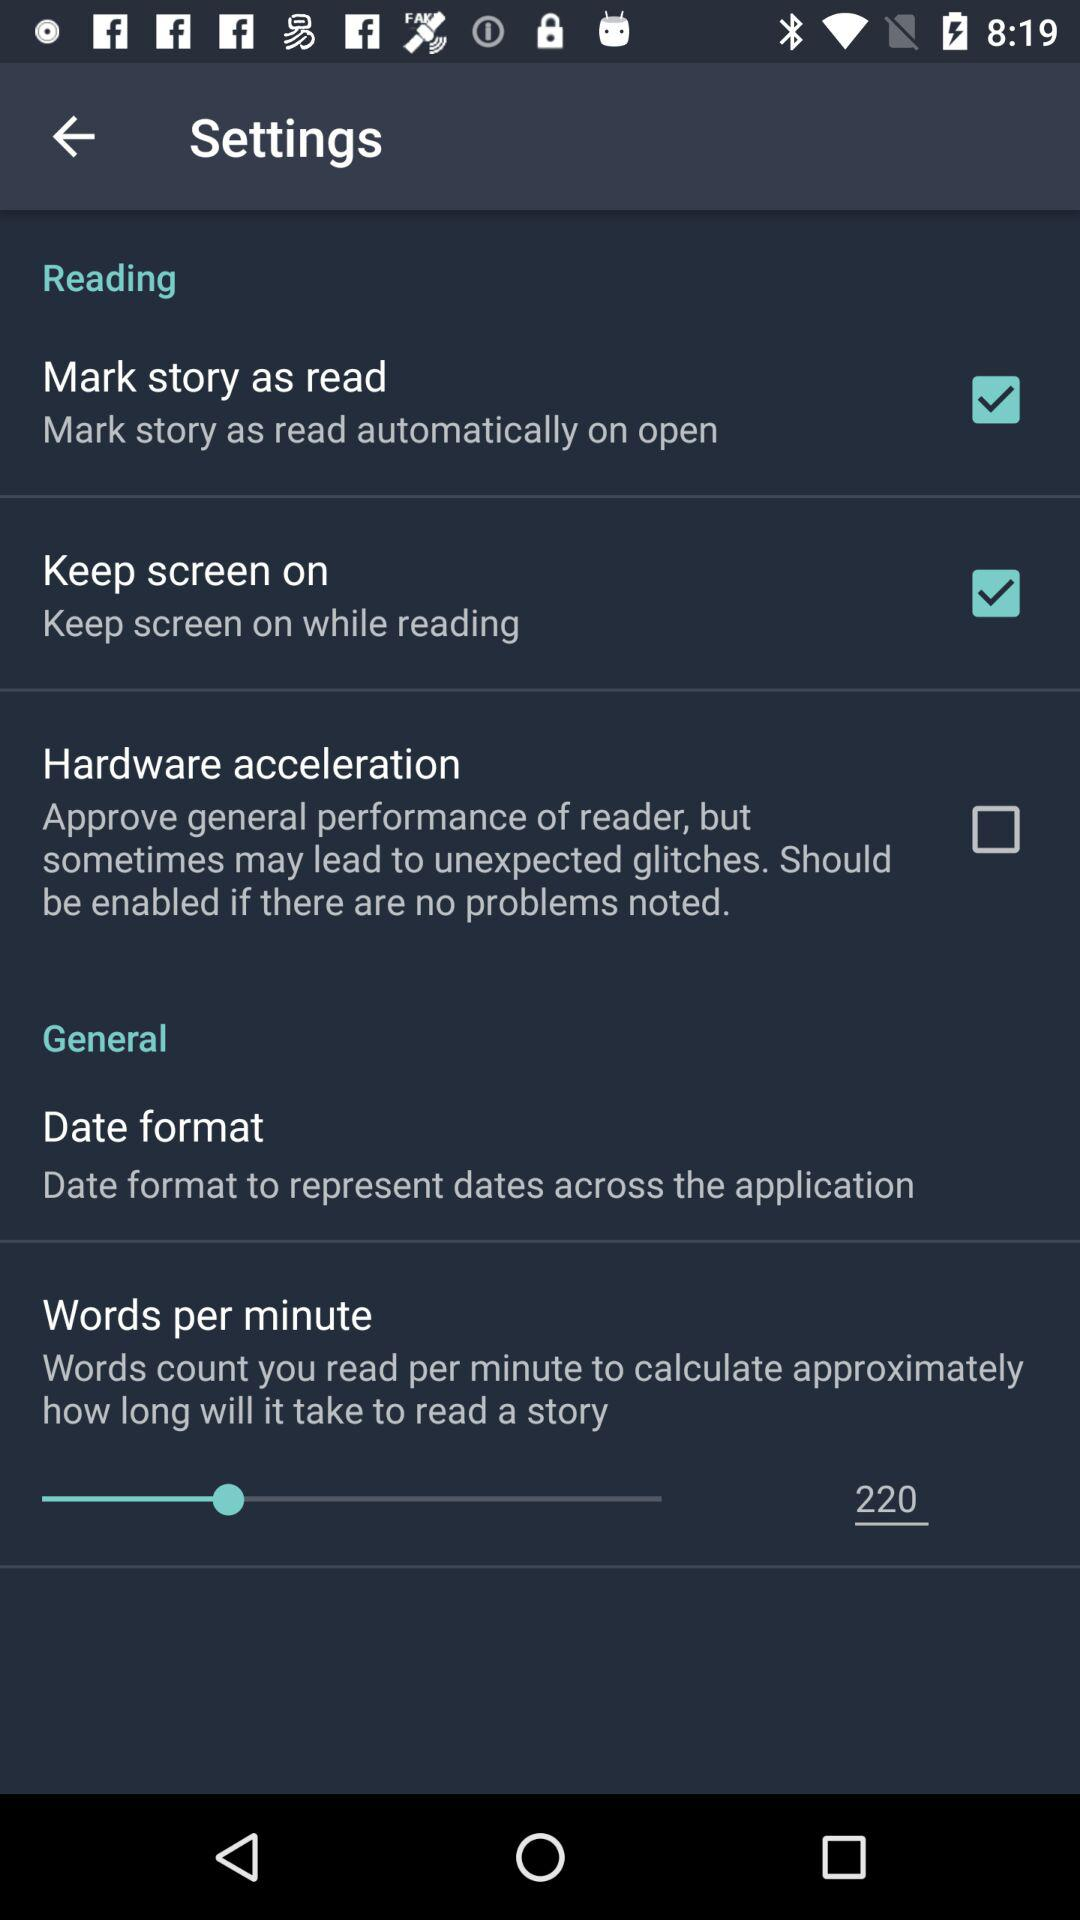How many words per minute are there? There are 220 words per minute. 